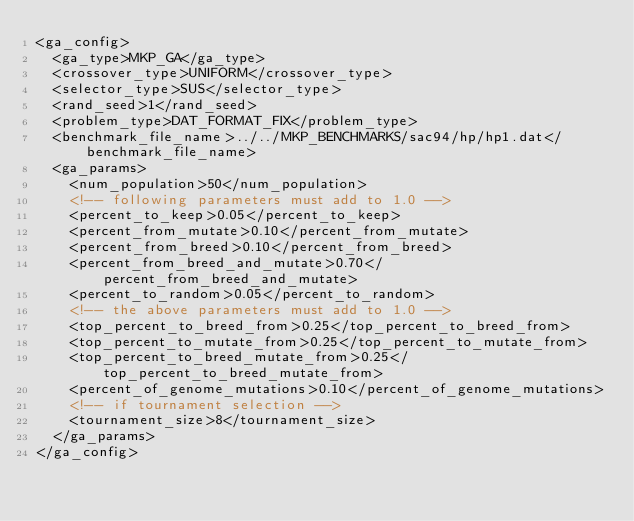Convert code to text. <code><loc_0><loc_0><loc_500><loc_500><_XML_><ga_config>
	<ga_type>MKP_GA</ga_type>
	<crossover_type>UNIFORM</crossover_type>
	<selector_type>SUS</selector_type>
	<rand_seed>1</rand_seed>
	<problem_type>DAT_FORMAT_FIX</problem_type>
	<benchmark_file_name>../../MKP_BENCHMARKS/sac94/hp/hp1.dat</benchmark_file_name>
	<ga_params>
		<num_population>50</num_population>
		<!-- following parameters must add to 1.0 -->
		<percent_to_keep>0.05</percent_to_keep>
		<percent_from_mutate>0.10</percent_from_mutate>
		<percent_from_breed>0.10</percent_from_breed>
		<percent_from_breed_and_mutate>0.70</percent_from_breed_and_mutate>
		<percent_to_random>0.05</percent_to_random>
		<!-- the above parameters must add to 1.0 -->
		<top_percent_to_breed_from>0.25</top_percent_to_breed_from>
		<top_percent_to_mutate_from>0.25</top_percent_to_mutate_from>
		<top_percent_to_breed_mutate_from>0.25</top_percent_to_breed_mutate_from>
		<percent_of_genome_mutations>0.10</percent_of_genome_mutations>
		<!-- if tournament selection -->
		<tournament_size>8</tournament_size>
	</ga_params>
</ga_config>
</code> 